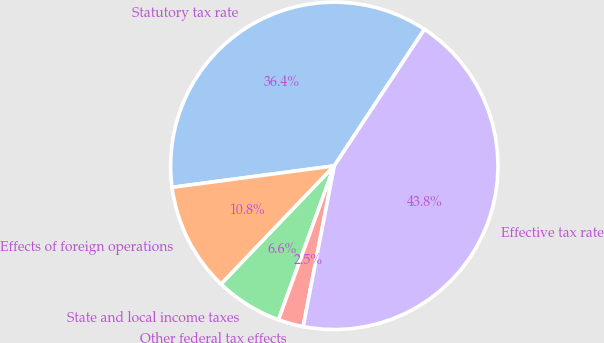<chart> <loc_0><loc_0><loc_500><loc_500><pie_chart><fcel>Statutory tax rate<fcel>Effects of foreign operations<fcel>State and local income taxes<fcel>Other federal tax effects<fcel>Effective tax rate<nl><fcel>36.38%<fcel>10.75%<fcel>6.62%<fcel>2.49%<fcel>43.76%<nl></chart> 